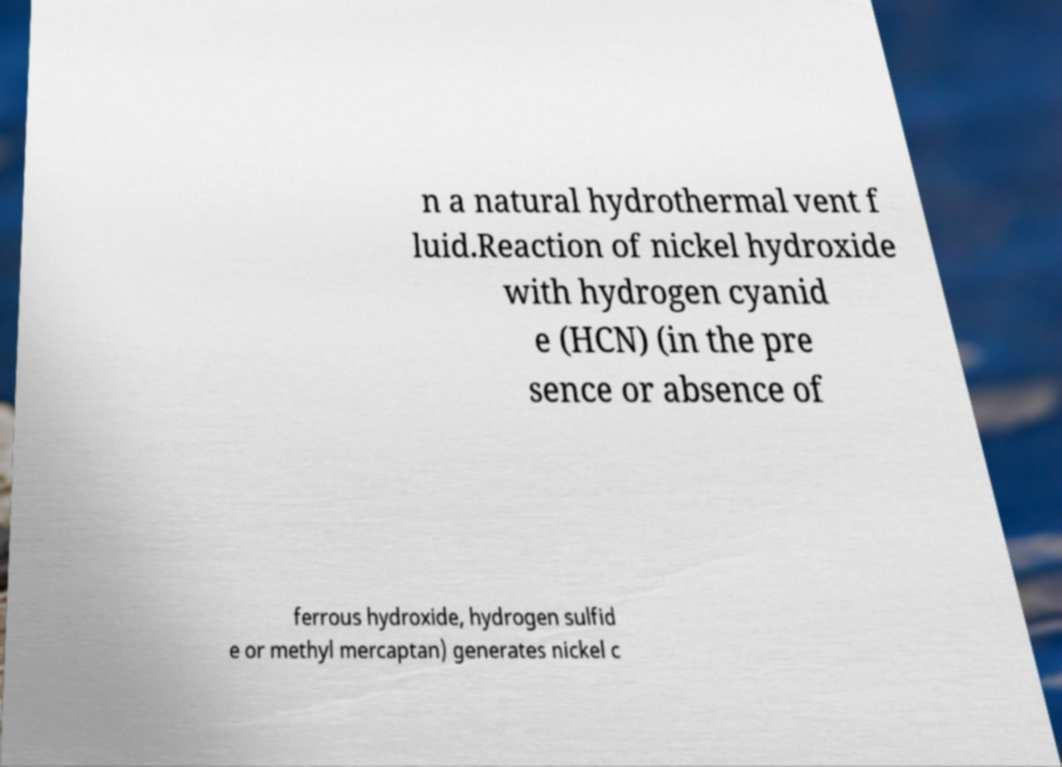What messages or text are displayed in this image? I need them in a readable, typed format. n a natural hydrothermal vent f luid.Reaction of nickel hydroxide with hydrogen cyanid e (HCN) (in the pre sence or absence of ferrous hydroxide, hydrogen sulfid e or methyl mercaptan) generates nickel c 